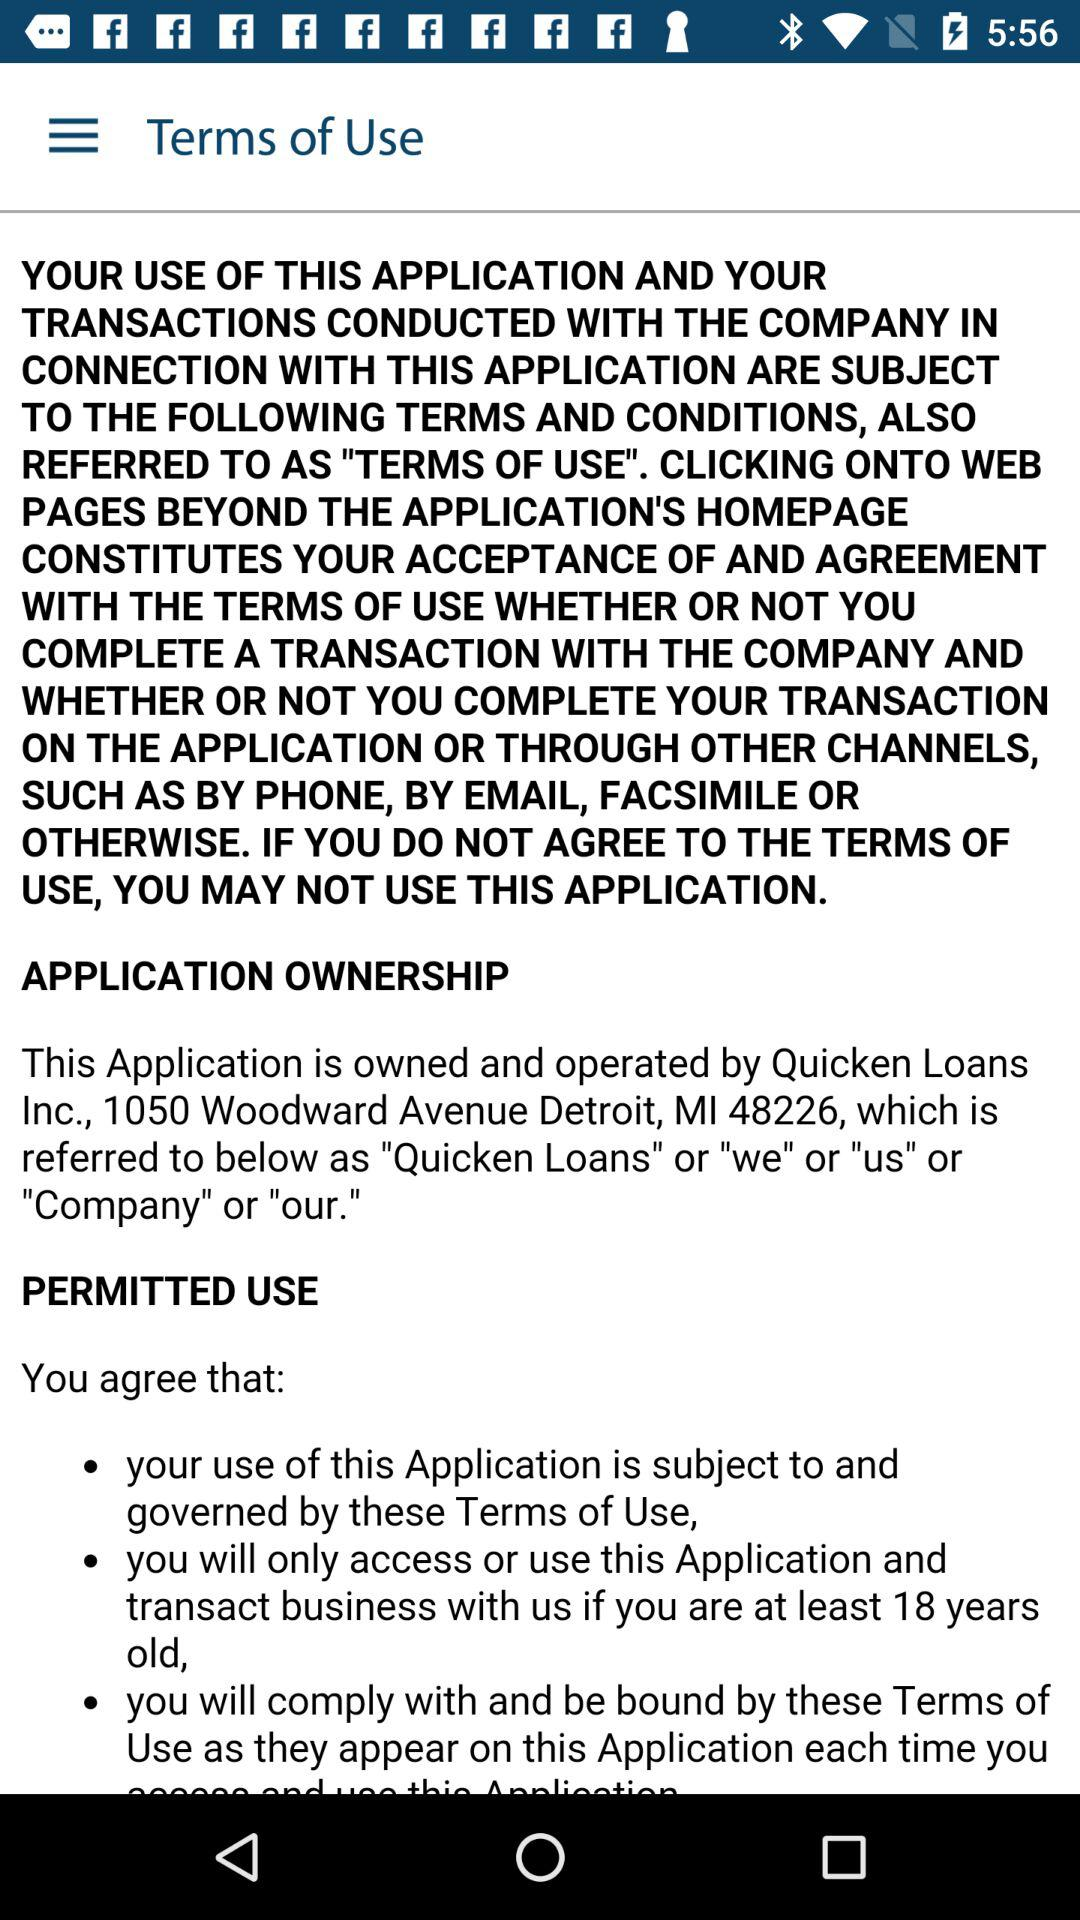What are the terms of use? The terms of use is "Your use of this application and your Transactions conducted with the company in connection with this application are subject to the following terms and conditions, also referred to as "terms of use". Clicking onto web pages beyond the application's homepage constitutes your acceptance of and agreement with the terms of use whether or not you complete a transaction with the company and whether or not you complete your transaction on the application or through other channels, such as by phone, by email, facsimile or otherwise. If you do not agree to the terms of use, you may not use this application". 